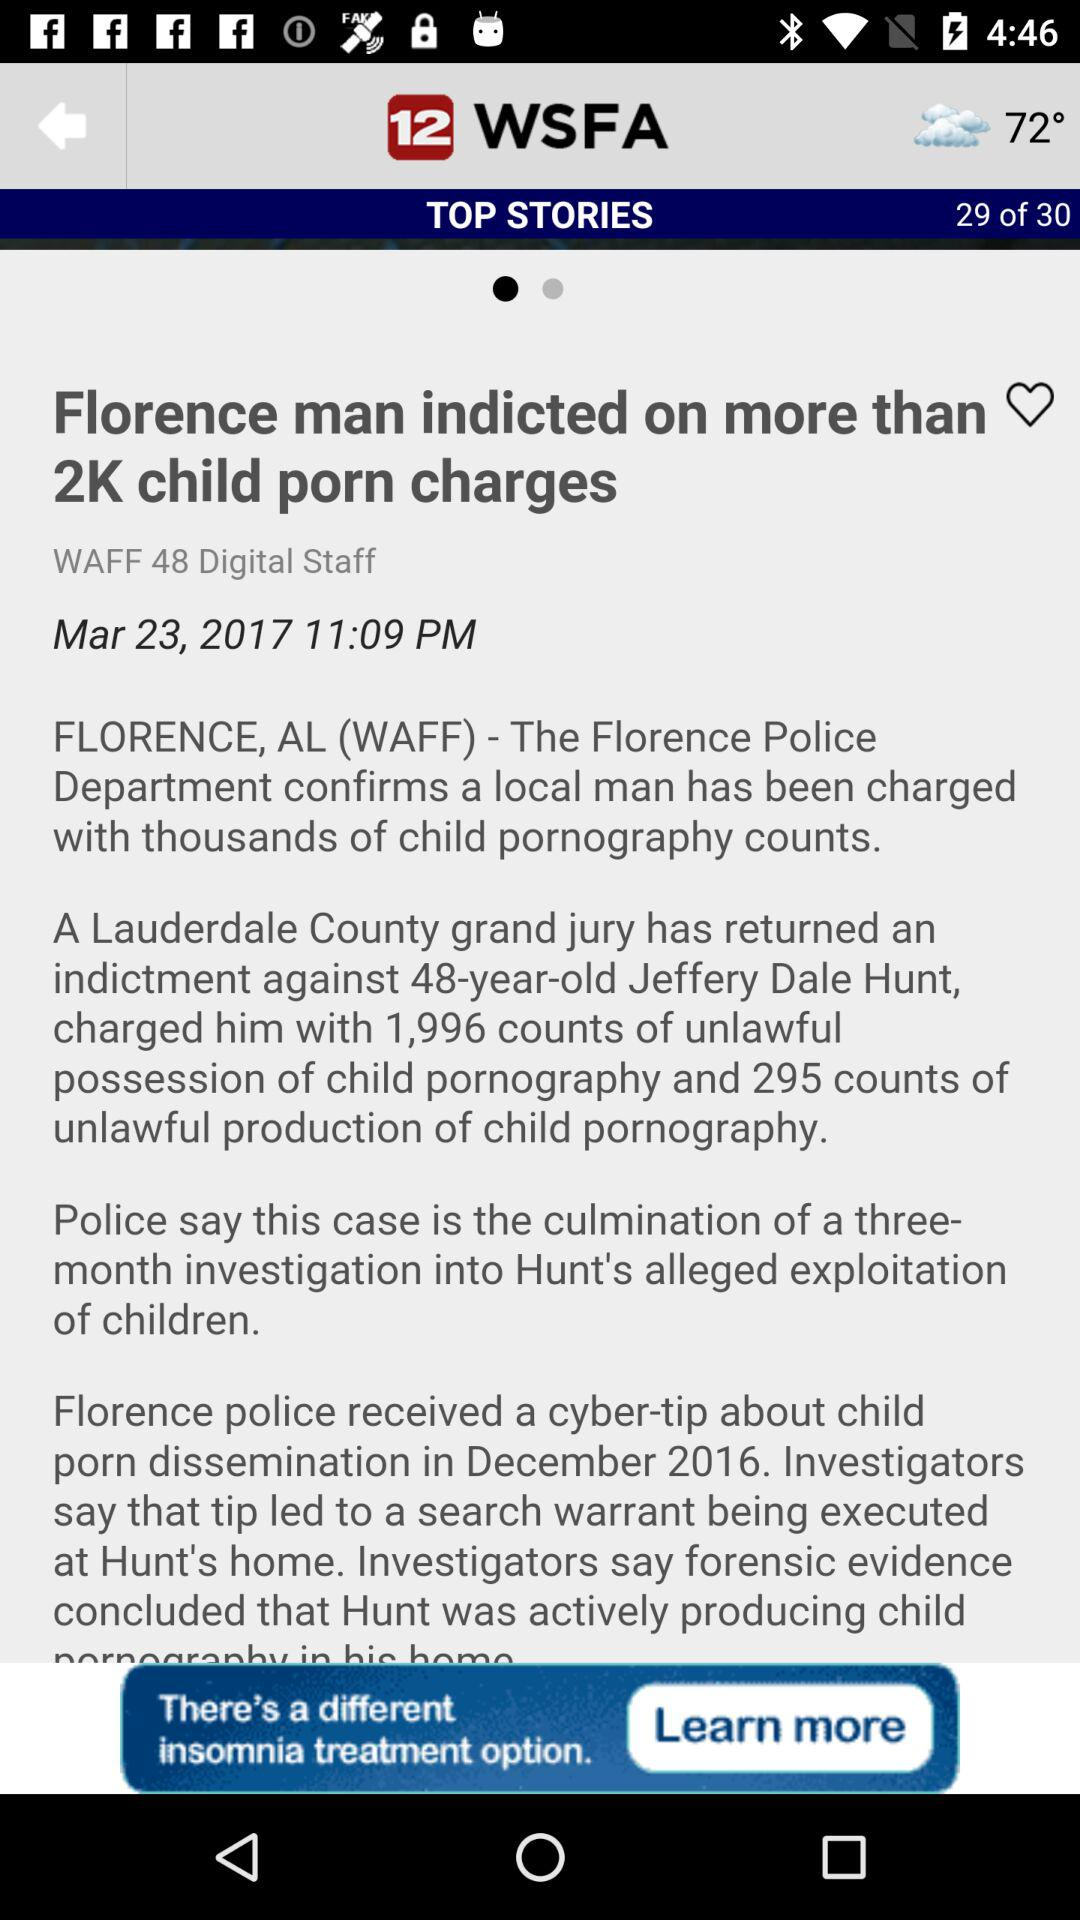What is the news channel name? The news channel name is 12 WSFA. 